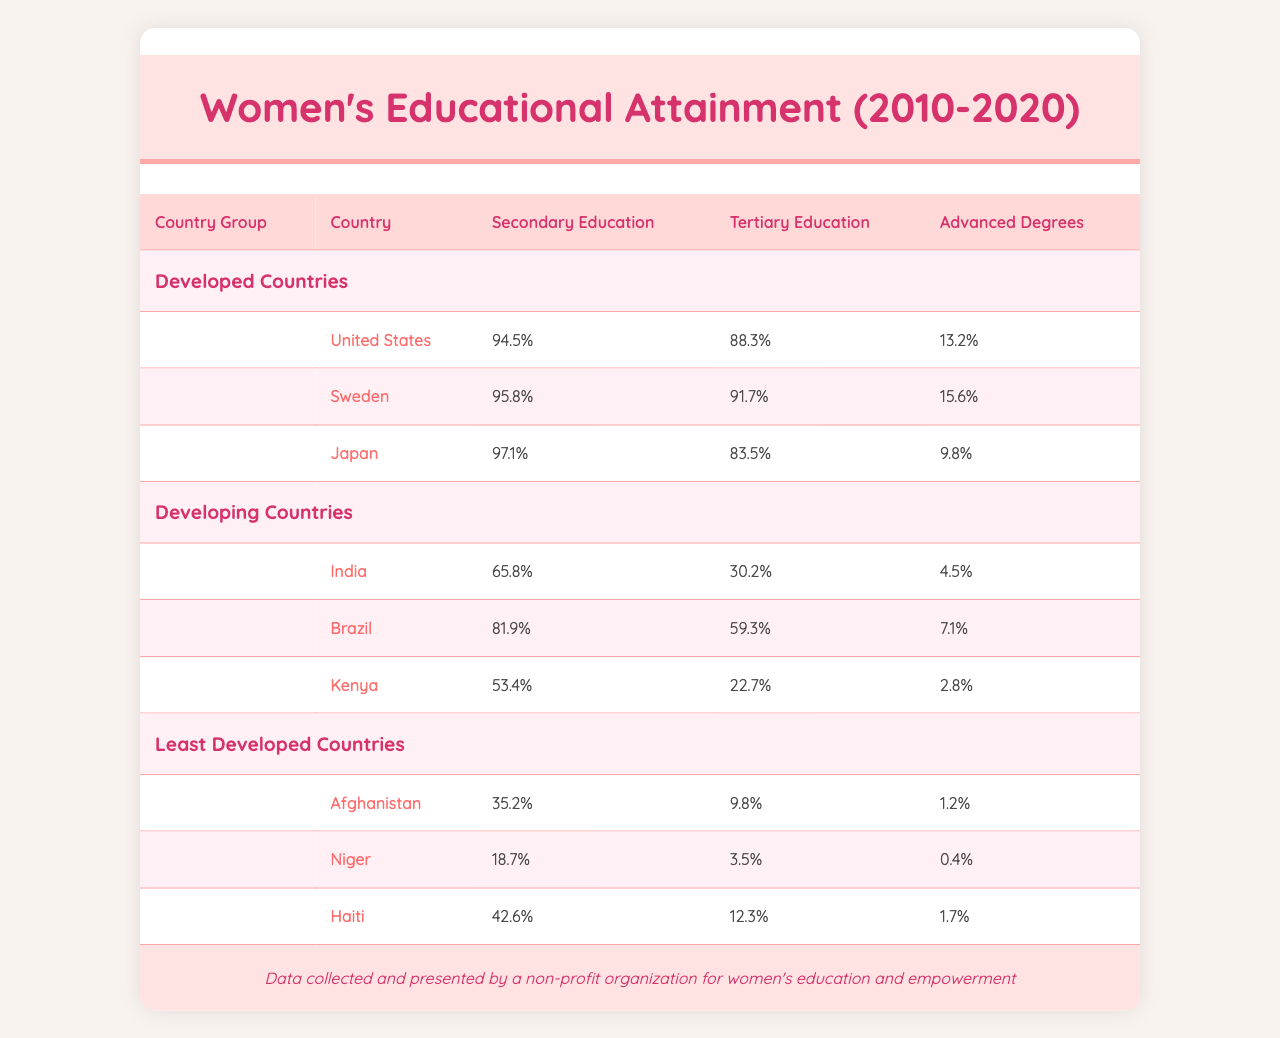What is the percentage of women who completed secondary education in Sweden? In the table, Sweden's row shows that the percentage of women who completed secondary education is 95.8%.
Answer: 95.8% Which country has the lowest percentage of women with advanced degrees among the Least Developed Countries? The table indicates that among the Least Developed Countries, Niger has the lowest percentage of women with advanced degrees at 0.4%.
Answer: 0.4% What is the average percentage of tertiary education attainment for women in Developed Countries? To find the average, sum the percentages of tertiary education in Developed Countries: (88.3 + 91.7 + 83.5) = 263.5 and divide by 3 (number of countries) giving 263.5 / 3 = 87.83.
Answer: 87.83% Is the percentage of women with tertiary education in Brazil higher than in India? The table shows Brazil's tertiary education percentage is 59.3% and India's is 30.2%, so yes, Brazil's percentage is higher than India's.
Answer: Yes What is the difference in the percentage of women who completed secondary education between Japan and Kenya? Japan has a percentage of 97.1% for secondary education, while Kenya has 53.4%. The difference is 97.1 - 53.4 = 43.7%.
Answer: 43.7% Which country in the Developed Countries group has the highest percentage of women with advanced degrees? From the data presented, Sweden has the highest percentage of advanced degrees at 15.6% among Developed Countries.
Answer: 15.6% What is the total percentage of women who completed secondary education across all Least Developed Countries? The percentages for secondary education in Least Developed Countries are 35.2 (Afghanistan) + 18.7 (Niger) + 42.6 (Haiti) = 96.5%.
Answer: 96.5% Which Developed Country has a higher percentage of women with tertiary education: the United States or Japan? The United States has a tertiary education percentage of 88.3% while Japan has 83.5%, so the United States has a higher percentage.
Answer: United States What is the median percentage of advanced degrees for women across all countries listed? To find the median, the advanced degrees percentages are organized as follows: 0.4 (Niger), 1.2 (Afghanistan), 1.7 (Haiti), 2.8 (Kenya), 4.5 (India), 7.1 (Brazil), 9.8 (Japan), 13.2 (United States), and 15.6 (Sweden). The middle values are 4.5 and 7.1, so the median is (4.5 + 7.1) / 2 = 5.8%.
Answer: 5.8% What percentage of women in Kenya have completed tertiary education? According to the table, Kenya has a tertiary education percentage of 22.7% for women.
Answer: 22.7% 